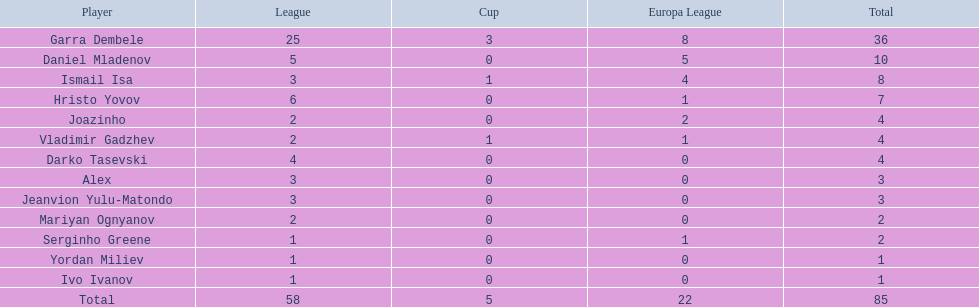Who are all the athletes? Garra Dembele, Daniel Mladenov, Ismail Isa, Hristo Yovov, Joazinho, Vladimir Gadzhev, Darko Tasevski, Alex, Jeanvion Yulu-Matondo, Mariyan Ognyanov, Serginho Greene, Yordan Miliev, Ivo Ivanov. And what league does each athlete belong to? 25, 5, 3, 6, 2, 2, 4, 3, 3, 2, 1, 1, 1. Apart from vladimir gadzhev and joazinho, who else is in league 2? Mariyan Ognyanov. 